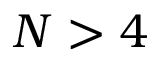<formula> <loc_0><loc_0><loc_500><loc_500>N > 4</formula> 